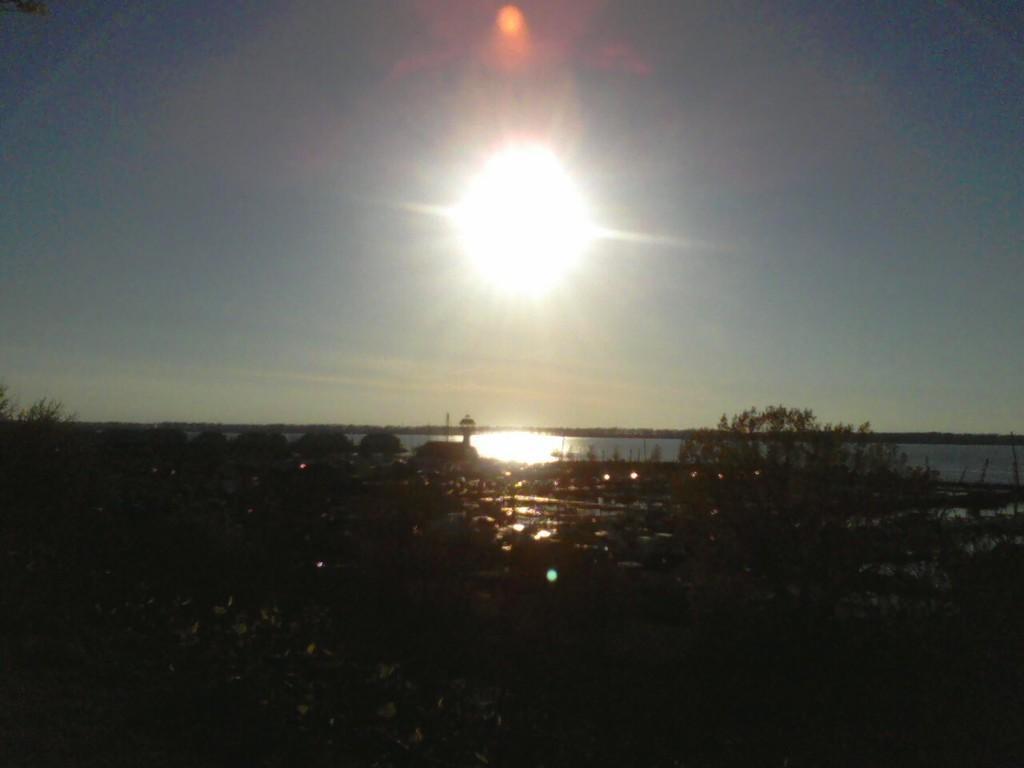Can you describe this image briefly? This picture is taken outside. At the bottom, there are plants and stones. In the center, there is a river. At the top, there is a sky with sun. 